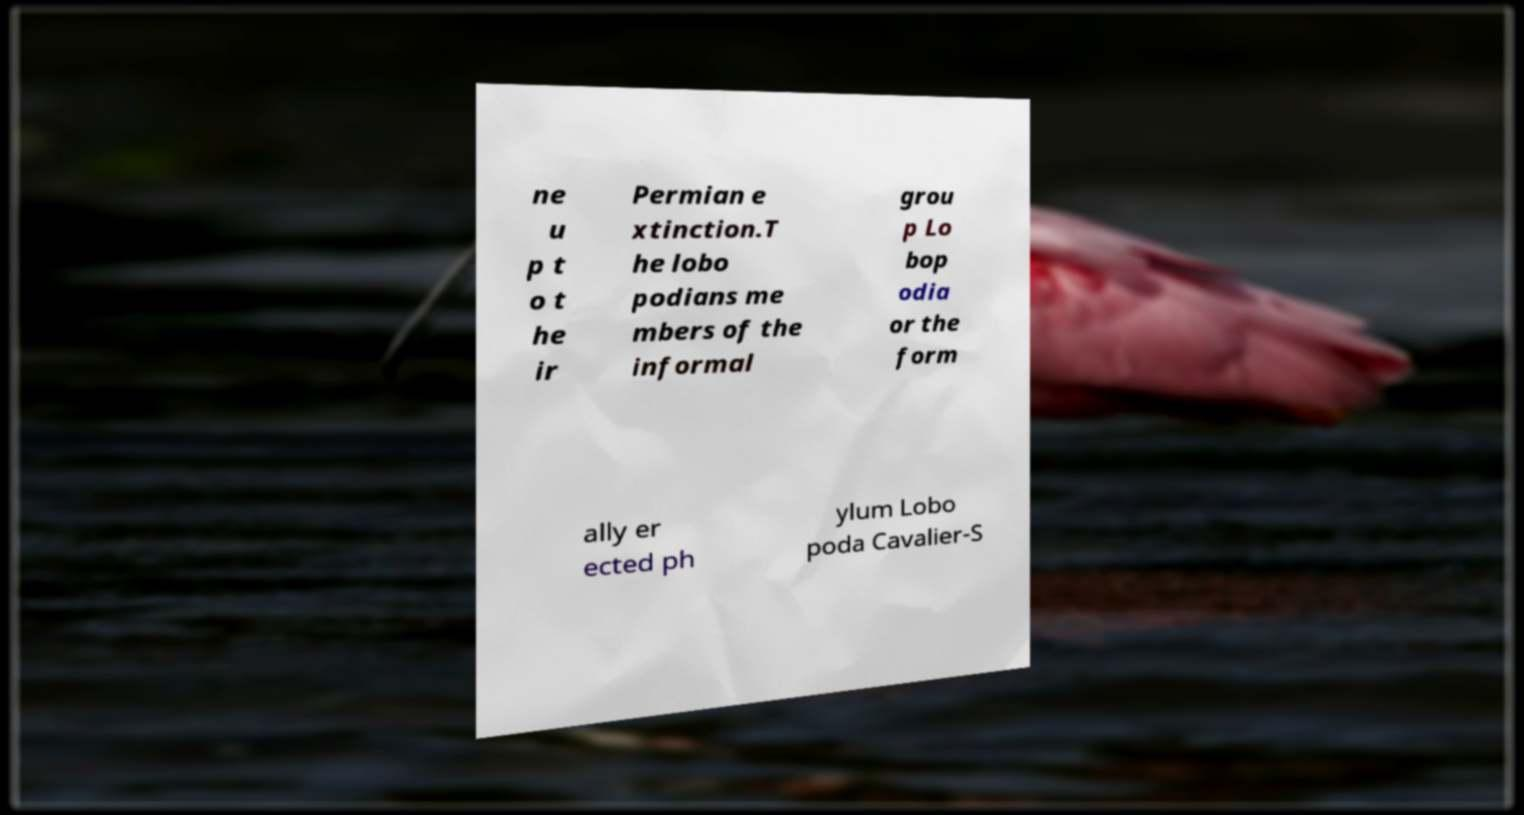Can you read and provide the text displayed in the image?This photo seems to have some interesting text. Can you extract and type it out for me? ne u p t o t he ir Permian e xtinction.T he lobo podians me mbers of the informal grou p Lo bop odia or the form ally er ected ph ylum Lobo poda Cavalier-S 